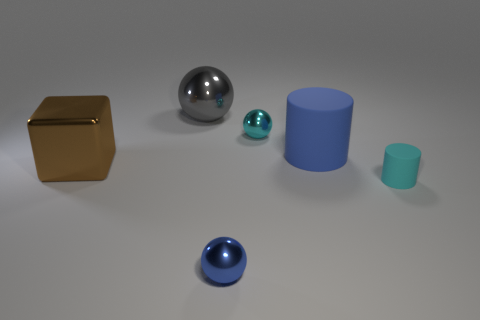Subtract all large gray spheres. How many spheres are left? 2 Subtract all cyan cylinders. How many cylinders are left? 1 Add 1 rubber cubes. How many objects exist? 7 Subtract all cubes. How many objects are left? 5 Subtract 1 spheres. How many spheres are left? 2 Add 4 blue things. How many blue things are left? 6 Add 4 tiny cyan objects. How many tiny cyan objects exist? 6 Subtract 0 gray cubes. How many objects are left? 6 Subtract all yellow balls. Subtract all cyan cylinders. How many balls are left? 3 Subtract all green balls. How many yellow blocks are left? 0 